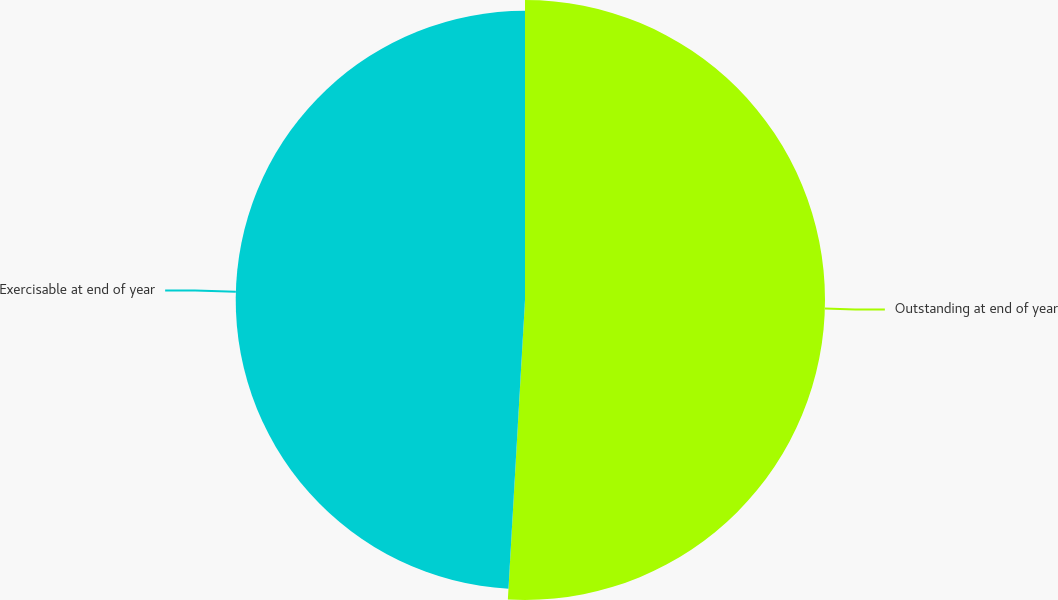Convert chart. <chart><loc_0><loc_0><loc_500><loc_500><pie_chart><fcel>Outstanding at end of year<fcel>Exercisable at end of year<nl><fcel>50.91%<fcel>49.09%<nl></chart> 